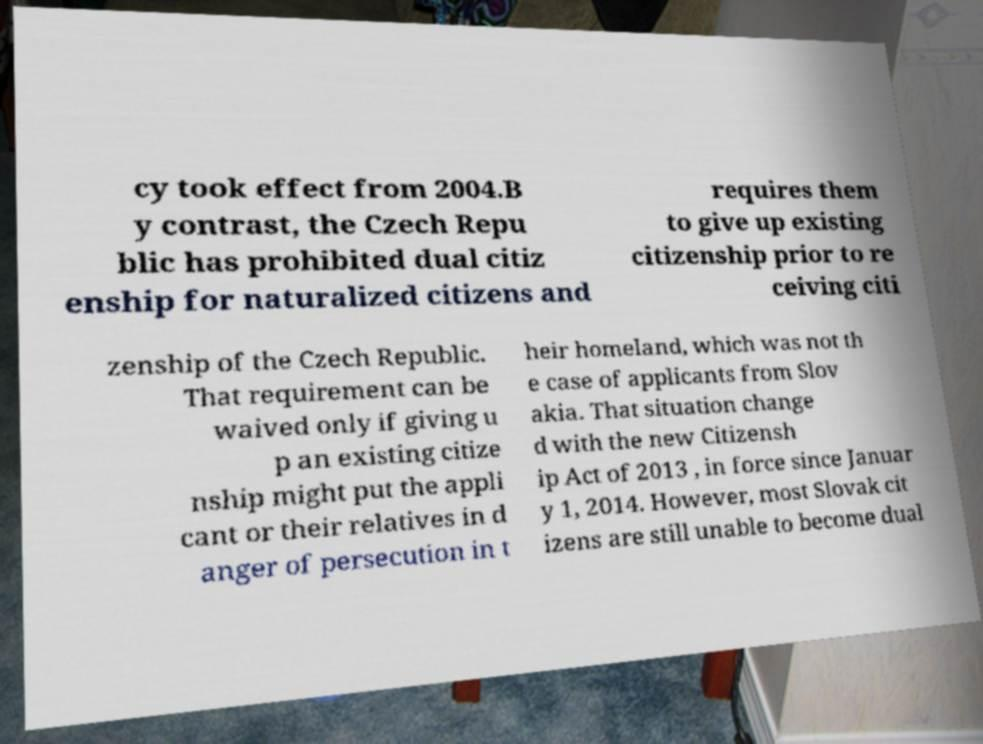Can you accurately transcribe the text from the provided image for me? cy took effect from 2004.B y contrast, the Czech Repu blic has prohibited dual citiz enship for naturalized citizens and requires them to give up existing citizenship prior to re ceiving citi zenship of the Czech Republic. That requirement can be waived only if giving u p an existing citize nship might put the appli cant or their relatives in d anger of persecution in t heir homeland, which was not th e case of applicants from Slov akia. That situation change d with the new Citizensh ip Act of 2013 , in force since Januar y 1, 2014. However, most Slovak cit izens are still unable to become dual 